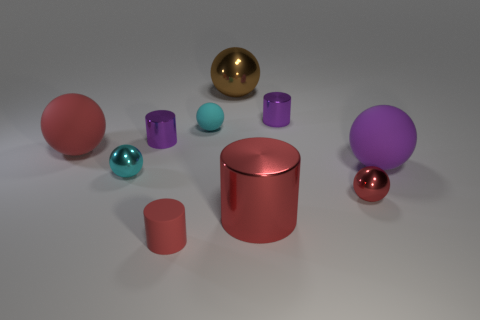Do the small rubber cylinder and the big cylinder have the same color?
Offer a very short reply. Yes. Are there any things that have the same color as the small matte ball?
Ensure brevity in your answer.  Yes. What shape is the purple rubber thing that is the same size as the brown thing?
Give a very brief answer. Sphere. Is the number of cyan rubber spheres less than the number of tiny metallic cylinders?
Provide a succinct answer. Yes. What number of red things are the same size as the red matte cylinder?
Give a very brief answer. 1. There is a big shiny thing that is the same color as the small matte cylinder; what shape is it?
Provide a short and direct response. Cylinder. What is the material of the big brown thing?
Your response must be concise. Metal. What size is the red ball that is on the right side of the large brown object?
Provide a short and direct response. Small. What number of small shiny objects have the same shape as the tiny cyan rubber thing?
Make the answer very short. 2. What is the shape of the red object that is made of the same material as the big red ball?
Provide a succinct answer. Cylinder. 